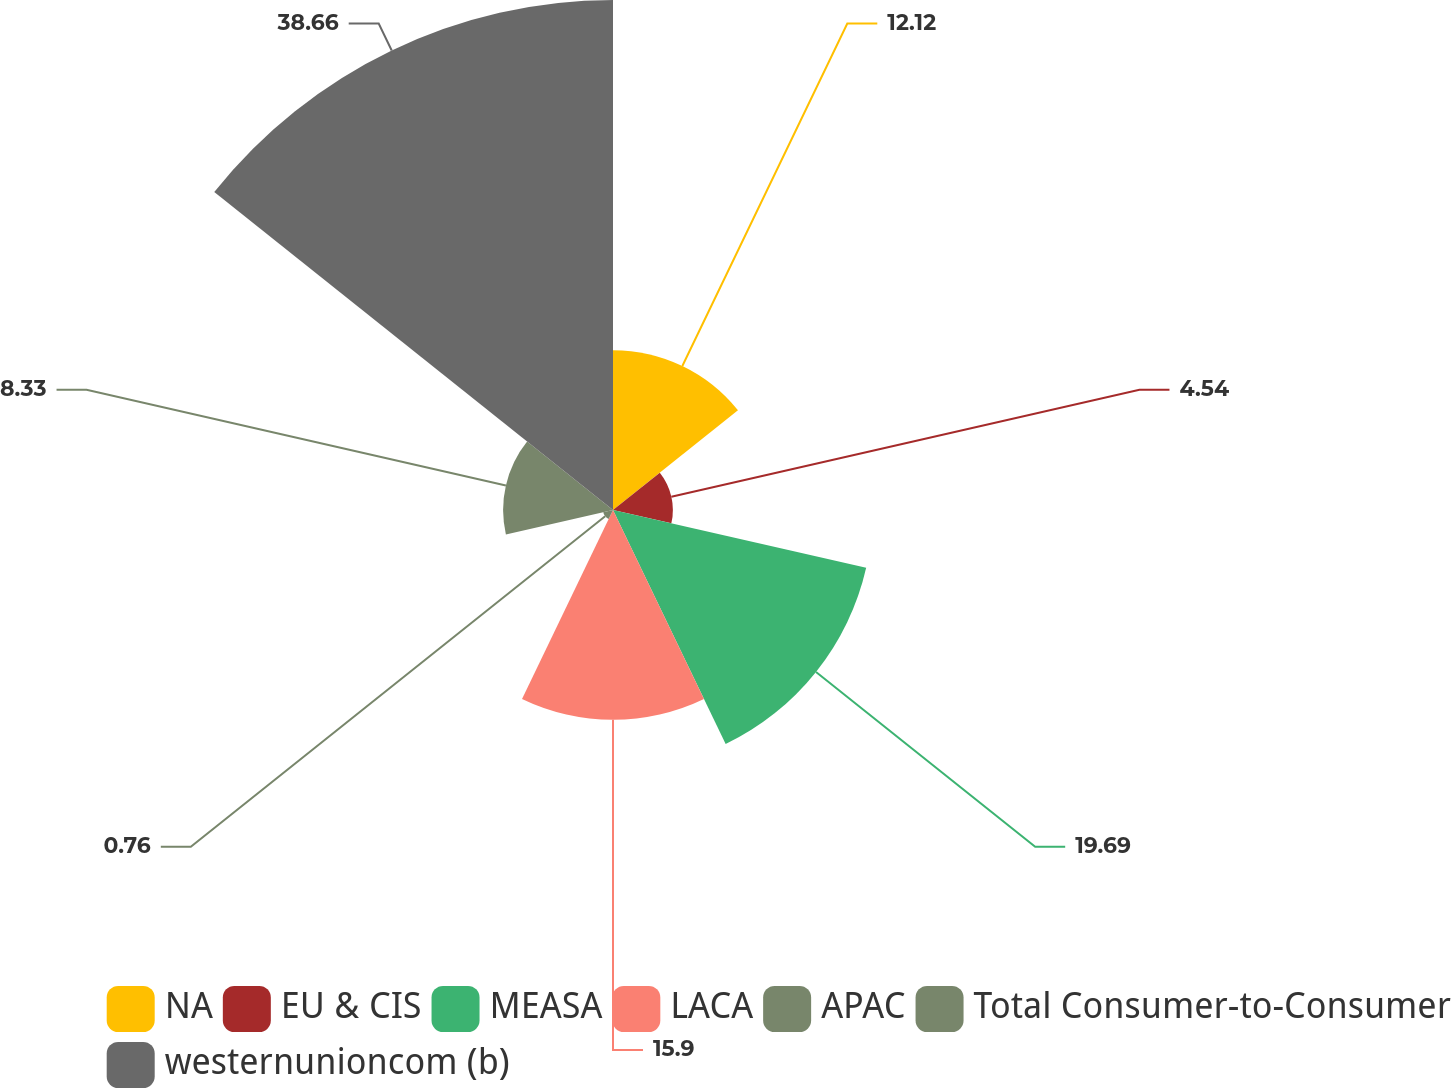<chart> <loc_0><loc_0><loc_500><loc_500><pie_chart><fcel>NA<fcel>EU & CIS<fcel>MEASA<fcel>LACA<fcel>APAC<fcel>Total Consumer-to-Consumer<fcel>westernunioncom (b)<nl><fcel>12.12%<fcel>4.54%<fcel>19.69%<fcel>15.9%<fcel>0.76%<fcel>8.33%<fcel>38.67%<nl></chart> 